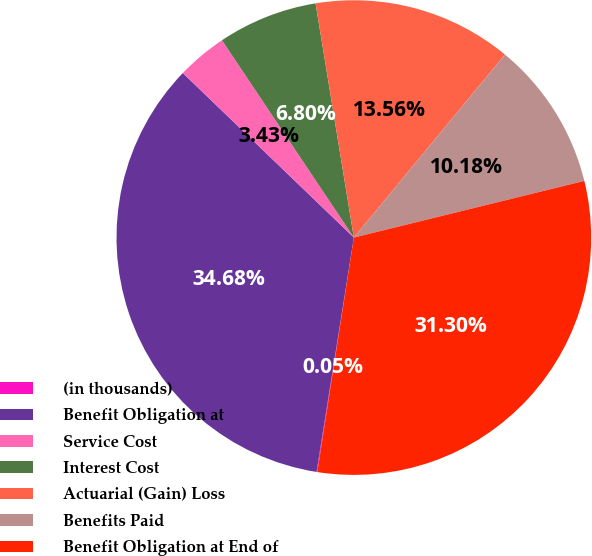<chart> <loc_0><loc_0><loc_500><loc_500><pie_chart><fcel>(in thousands)<fcel>Benefit Obligation at<fcel>Service Cost<fcel>Interest Cost<fcel>Actuarial (Gain) Loss<fcel>Benefits Paid<fcel>Benefit Obligation at End of<nl><fcel>0.05%<fcel>34.68%<fcel>3.43%<fcel>6.8%<fcel>13.56%<fcel>10.18%<fcel>31.3%<nl></chart> 